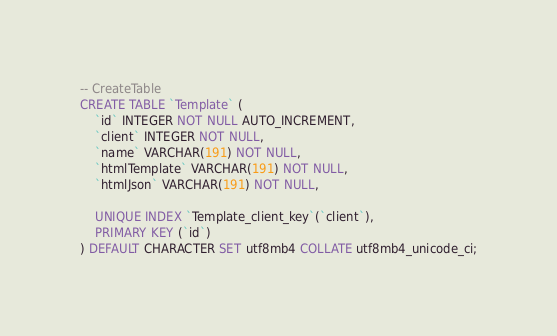Convert code to text. <code><loc_0><loc_0><loc_500><loc_500><_SQL_>-- CreateTable
CREATE TABLE `Template` (
    `id` INTEGER NOT NULL AUTO_INCREMENT,
    `client` INTEGER NOT NULL,
    `name` VARCHAR(191) NOT NULL,
    `htmlTemplate` VARCHAR(191) NOT NULL,
    `htmlJson` VARCHAR(191) NOT NULL,

    UNIQUE INDEX `Template_client_key`(`client`),
    PRIMARY KEY (`id`)
) DEFAULT CHARACTER SET utf8mb4 COLLATE utf8mb4_unicode_ci;
</code> 